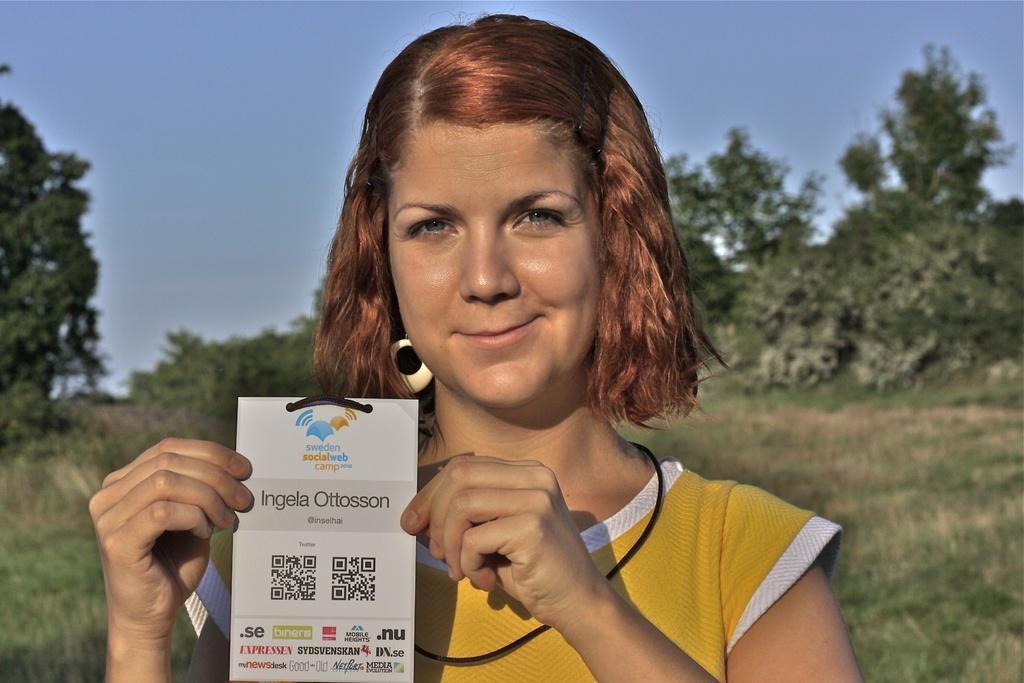How would you summarize this image in a sentence or two? There is a lady wearing a tag and holding the tag in the hand. On the tag there is something written. In the background there are trees and sky. On the ground there is grass. 